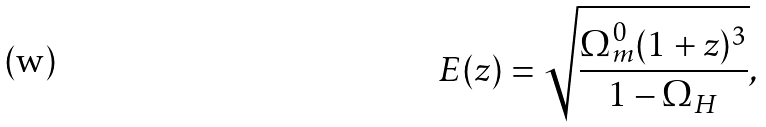<formula> <loc_0><loc_0><loc_500><loc_500>E ( z ) = \sqrt { \frac { \Omega ^ { 0 } _ { m } ( 1 + z ) ^ { 3 } } { 1 - \Omega _ { H } } } ,</formula> 